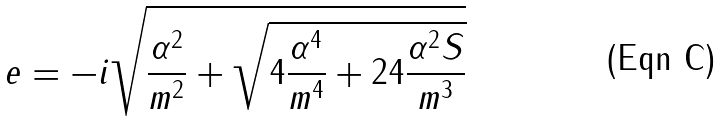Convert formula to latex. <formula><loc_0><loc_0><loc_500><loc_500>e = - i \sqrt { \frac { \alpha ^ { 2 } } { m ^ { 2 } } + \sqrt { 4 \frac { \alpha ^ { 4 } } { m ^ { 4 } } + 2 4 \frac { \alpha ^ { 2 } S } { m ^ { 3 } } } }</formula> 